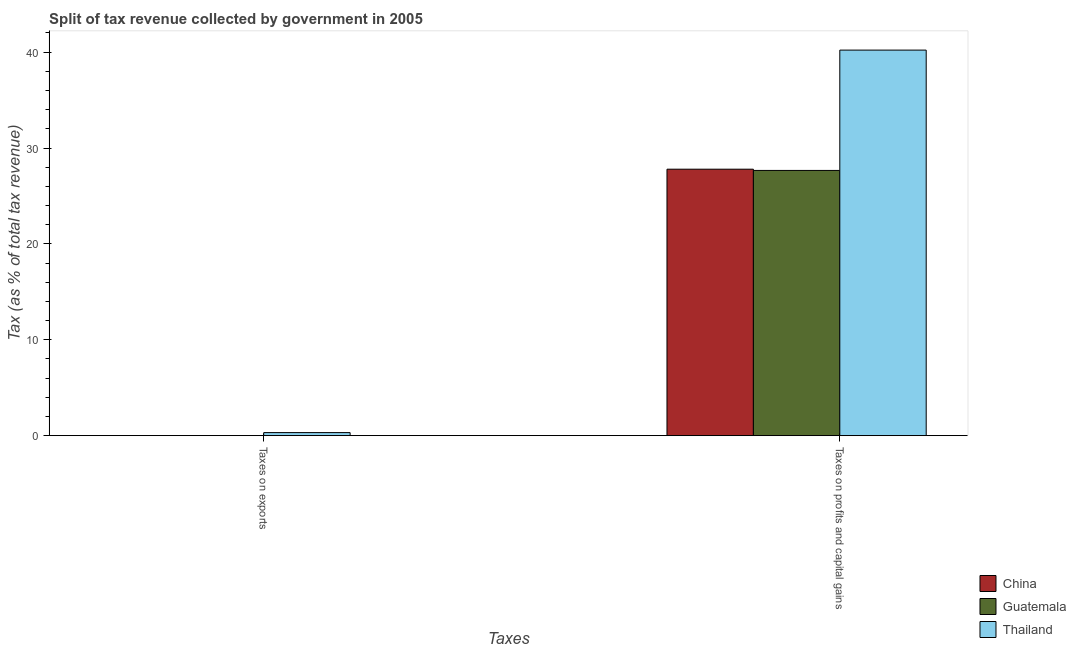How many different coloured bars are there?
Keep it short and to the point. 3. Are the number of bars on each tick of the X-axis equal?
Offer a very short reply. No. How many bars are there on the 1st tick from the left?
Make the answer very short. 2. What is the label of the 1st group of bars from the left?
Keep it short and to the point. Taxes on exports. Across all countries, what is the maximum percentage of revenue obtained from taxes on exports?
Provide a succinct answer. 0.32. Across all countries, what is the minimum percentage of revenue obtained from taxes on exports?
Your response must be concise. 0. In which country was the percentage of revenue obtained from taxes on exports maximum?
Ensure brevity in your answer.  Thailand. What is the total percentage of revenue obtained from taxes on profits and capital gains in the graph?
Your answer should be very brief. 95.66. What is the difference between the percentage of revenue obtained from taxes on exports in Guatemala and that in Thailand?
Provide a short and direct response. -0.31. What is the difference between the percentage of revenue obtained from taxes on exports in Guatemala and the percentage of revenue obtained from taxes on profits and capital gains in Thailand?
Your response must be concise. -40.21. What is the average percentage of revenue obtained from taxes on profits and capital gains per country?
Your response must be concise. 31.89. What is the difference between the percentage of revenue obtained from taxes on profits and capital gains and percentage of revenue obtained from taxes on exports in Guatemala?
Your response must be concise. 27.66. What is the ratio of the percentage of revenue obtained from taxes on profits and capital gains in China to that in Guatemala?
Ensure brevity in your answer.  1. In how many countries, is the percentage of revenue obtained from taxes on profits and capital gains greater than the average percentage of revenue obtained from taxes on profits and capital gains taken over all countries?
Offer a terse response. 1. Are all the bars in the graph horizontal?
Provide a short and direct response. No. Does the graph contain any zero values?
Keep it short and to the point. Yes. Where does the legend appear in the graph?
Keep it short and to the point. Bottom right. How are the legend labels stacked?
Your answer should be compact. Vertical. What is the title of the graph?
Provide a short and direct response. Split of tax revenue collected by government in 2005. What is the label or title of the X-axis?
Provide a short and direct response. Taxes. What is the label or title of the Y-axis?
Your answer should be compact. Tax (as % of total tax revenue). What is the Tax (as % of total tax revenue) of China in Taxes on exports?
Provide a succinct answer. 0. What is the Tax (as % of total tax revenue) in Guatemala in Taxes on exports?
Your response must be concise. 0. What is the Tax (as % of total tax revenue) of Thailand in Taxes on exports?
Provide a short and direct response. 0.32. What is the Tax (as % of total tax revenue) of China in Taxes on profits and capital gains?
Your answer should be compact. 27.79. What is the Tax (as % of total tax revenue) of Guatemala in Taxes on profits and capital gains?
Make the answer very short. 27.66. What is the Tax (as % of total tax revenue) of Thailand in Taxes on profits and capital gains?
Your answer should be compact. 40.21. Across all Taxes, what is the maximum Tax (as % of total tax revenue) in China?
Give a very brief answer. 27.79. Across all Taxes, what is the maximum Tax (as % of total tax revenue) in Guatemala?
Provide a short and direct response. 27.66. Across all Taxes, what is the maximum Tax (as % of total tax revenue) of Thailand?
Keep it short and to the point. 40.21. Across all Taxes, what is the minimum Tax (as % of total tax revenue) in Guatemala?
Offer a very short reply. 0. Across all Taxes, what is the minimum Tax (as % of total tax revenue) in Thailand?
Provide a short and direct response. 0.32. What is the total Tax (as % of total tax revenue) in China in the graph?
Keep it short and to the point. 27.79. What is the total Tax (as % of total tax revenue) in Guatemala in the graph?
Offer a terse response. 27.67. What is the total Tax (as % of total tax revenue) in Thailand in the graph?
Your response must be concise. 40.53. What is the difference between the Tax (as % of total tax revenue) in Guatemala in Taxes on exports and that in Taxes on profits and capital gains?
Offer a very short reply. -27.66. What is the difference between the Tax (as % of total tax revenue) in Thailand in Taxes on exports and that in Taxes on profits and capital gains?
Your answer should be very brief. -39.89. What is the difference between the Tax (as % of total tax revenue) of Guatemala in Taxes on exports and the Tax (as % of total tax revenue) of Thailand in Taxes on profits and capital gains?
Make the answer very short. -40.21. What is the average Tax (as % of total tax revenue) of China per Taxes?
Your response must be concise. 13.9. What is the average Tax (as % of total tax revenue) in Guatemala per Taxes?
Provide a short and direct response. 13.83. What is the average Tax (as % of total tax revenue) in Thailand per Taxes?
Provide a short and direct response. 20.26. What is the difference between the Tax (as % of total tax revenue) of Guatemala and Tax (as % of total tax revenue) of Thailand in Taxes on exports?
Make the answer very short. -0.31. What is the difference between the Tax (as % of total tax revenue) of China and Tax (as % of total tax revenue) of Guatemala in Taxes on profits and capital gains?
Provide a succinct answer. 0.13. What is the difference between the Tax (as % of total tax revenue) of China and Tax (as % of total tax revenue) of Thailand in Taxes on profits and capital gains?
Your answer should be compact. -12.42. What is the difference between the Tax (as % of total tax revenue) of Guatemala and Tax (as % of total tax revenue) of Thailand in Taxes on profits and capital gains?
Give a very brief answer. -12.55. What is the ratio of the Tax (as % of total tax revenue) of Guatemala in Taxes on exports to that in Taxes on profits and capital gains?
Your answer should be compact. 0. What is the ratio of the Tax (as % of total tax revenue) of Thailand in Taxes on exports to that in Taxes on profits and capital gains?
Keep it short and to the point. 0.01. What is the difference between the highest and the second highest Tax (as % of total tax revenue) of Guatemala?
Your answer should be very brief. 27.66. What is the difference between the highest and the second highest Tax (as % of total tax revenue) in Thailand?
Your answer should be very brief. 39.89. What is the difference between the highest and the lowest Tax (as % of total tax revenue) of China?
Your answer should be compact. 27.79. What is the difference between the highest and the lowest Tax (as % of total tax revenue) of Guatemala?
Offer a very short reply. 27.66. What is the difference between the highest and the lowest Tax (as % of total tax revenue) in Thailand?
Your answer should be very brief. 39.89. 